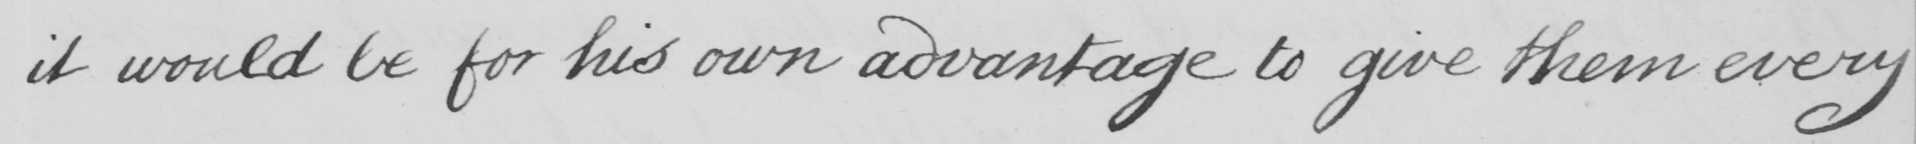Can you tell me what this handwritten text says? it would be for his own advantage to give them every 